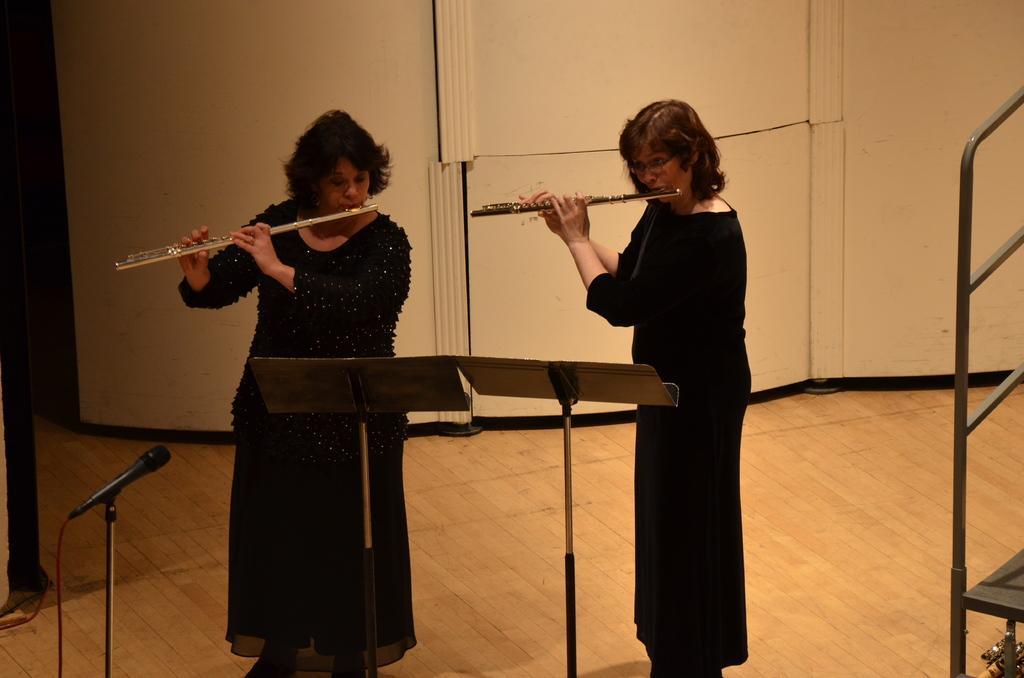Can you describe this image briefly? In this image we can see two ladies are playing flutes, there is a mic, and two stands, there are rods, also we can see the wall. 